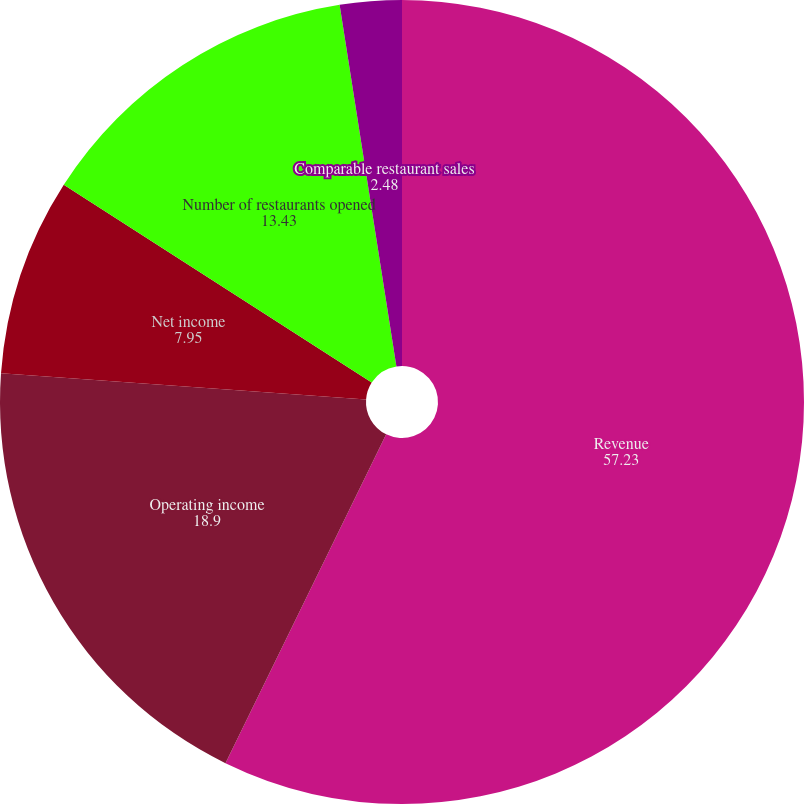<chart> <loc_0><loc_0><loc_500><loc_500><pie_chart><fcel>Revenue<fcel>Operating income<fcel>Net income<fcel>Number of restaurants opened<fcel>Comparable restaurant sales<nl><fcel>57.23%<fcel>18.9%<fcel>7.95%<fcel>13.43%<fcel>2.48%<nl></chart> 